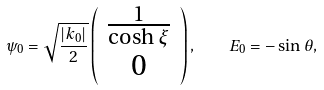Convert formula to latex. <formula><loc_0><loc_0><loc_500><loc_500>\psi _ { 0 } = \sqrt { \frac { | k _ { 0 } | } { 2 } } \left ( \begin{array} { c } \frac { 1 } { \cosh { \xi } } \\ 0 \end{array} \right ) , \quad E _ { 0 } = - \sin \theta ,</formula> 